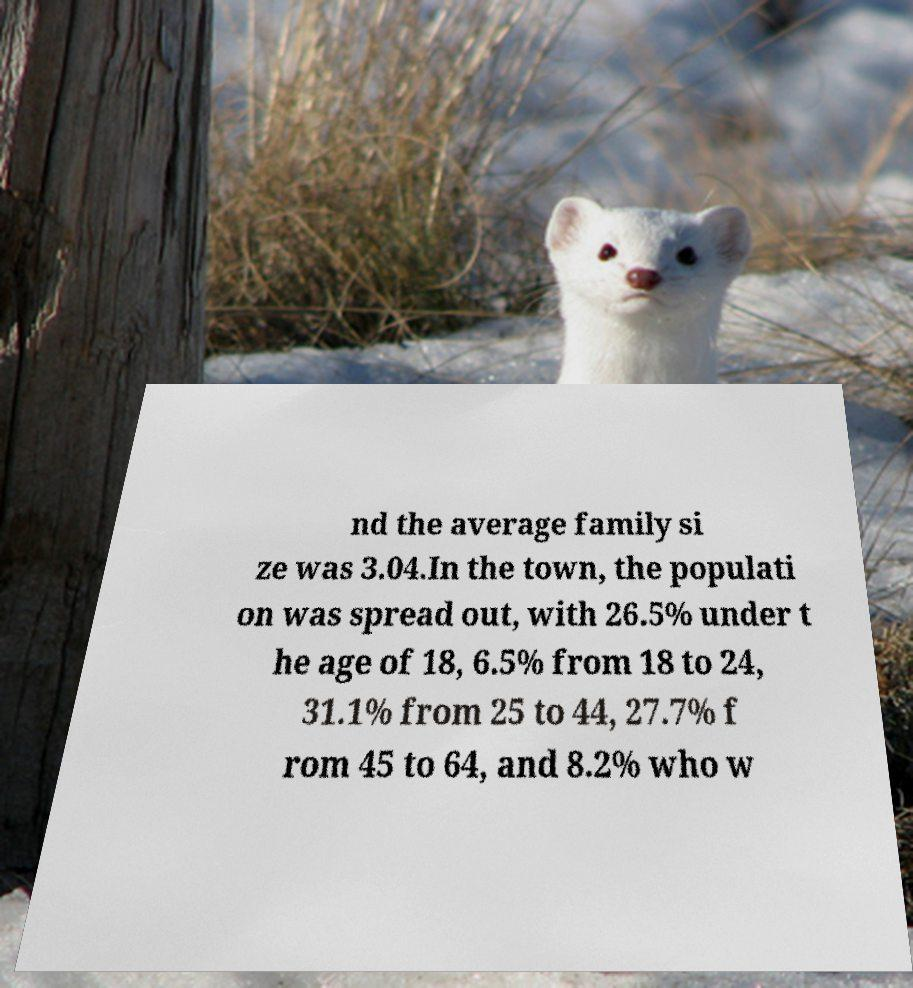For documentation purposes, I need the text within this image transcribed. Could you provide that? nd the average family si ze was 3.04.In the town, the populati on was spread out, with 26.5% under t he age of 18, 6.5% from 18 to 24, 31.1% from 25 to 44, 27.7% f rom 45 to 64, and 8.2% who w 